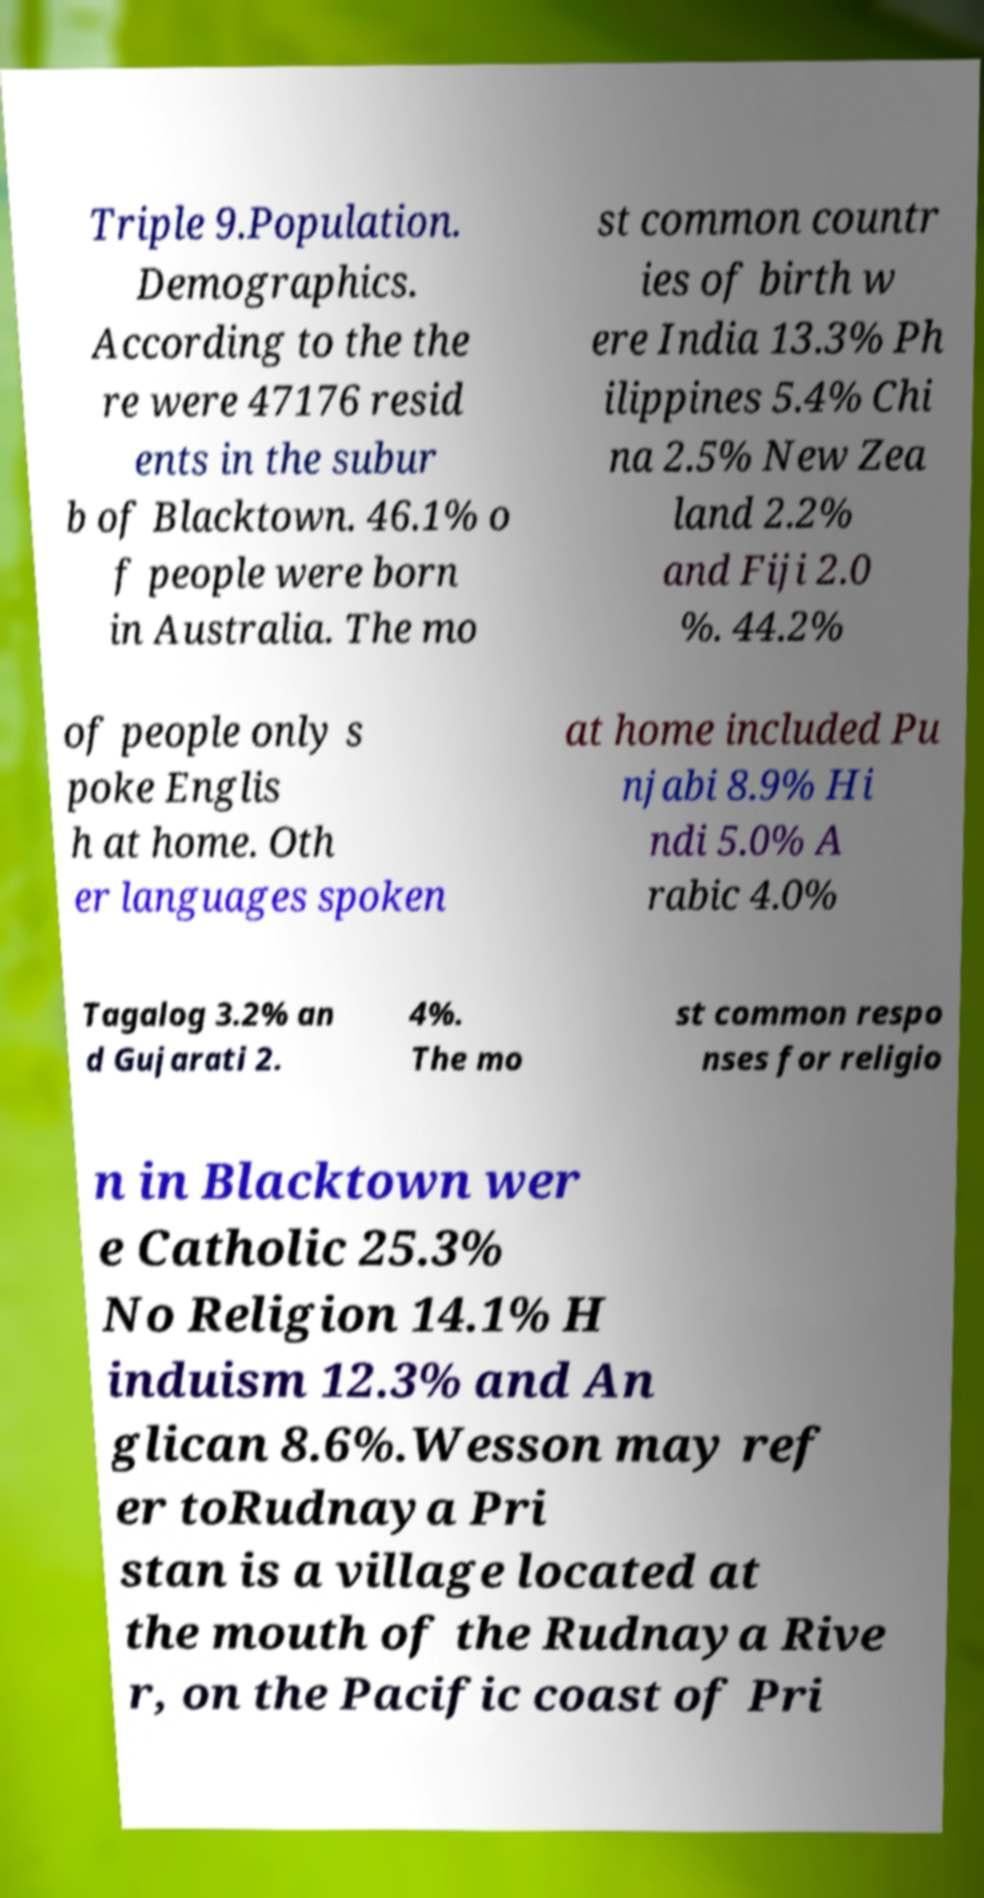There's text embedded in this image that I need extracted. Can you transcribe it verbatim? Triple 9.Population. Demographics. According to the the re were 47176 resid ents in the subur b of Blacktown. 46.1% o f people were born in Australia. The mo st common countr ies of birth w ere India 13.3% Ph ilippines 5.4% Chi na 2.5% New Zea land 2.2% and Fiji 2.0 %. 44.2% of people only s poke Englis h at home. Oth er languages spoken at home included Pu njabi 8.9% Hi ndi 5.0% A rabic 4.0% Tagalog 3.2% an d Gujarati 2. 4%. The mo st common respo nses for religio n in Blacktown wer e Catholic 25.3% No Religion 14.1% H induism 12.3% and An glican 8.6%.Wesson may ref er toRudnaya Pri stan is a village located at the mouth of the Rudnaya Rive r, on the Pacific coast of Pri 